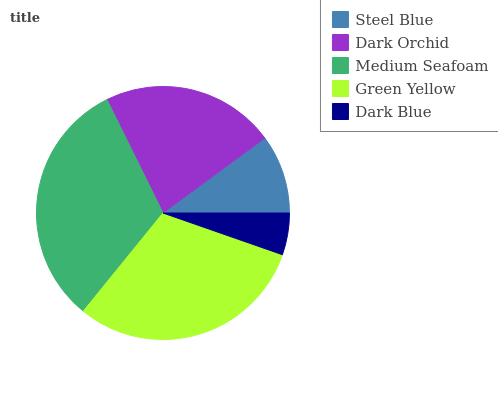Is Dark Blue the minimum?
Answer yes or no. Yes. Is Medium Seafoam the maximum?
Answer yes or no. Yes. Is Dark Orchid the minimum?
Answer yes or no. No. Is Dark Orchid the maximum?
Answer yes or no. No. Is Dark Orchid greater than Steel Blue?
Answer yes or no. Yes. Is Steel Blue less than Dark Orchid?
Answer yes or no. Yes. Is Steel Blue greater than Dark Orchid?
Answer yes or no. No. Is Dark Orchid less than Steel Blue?
Answer yes or no. No. Is Dark Orchid the high median?
Answer yes or no. Yes. Is Dark Orchid the low median?
Answer yes or no. Yes. Is Medium Seafoam the high median?
Answer yes or no. No. Is Medium Seafoam the low median?
Answer yes or no. No. 